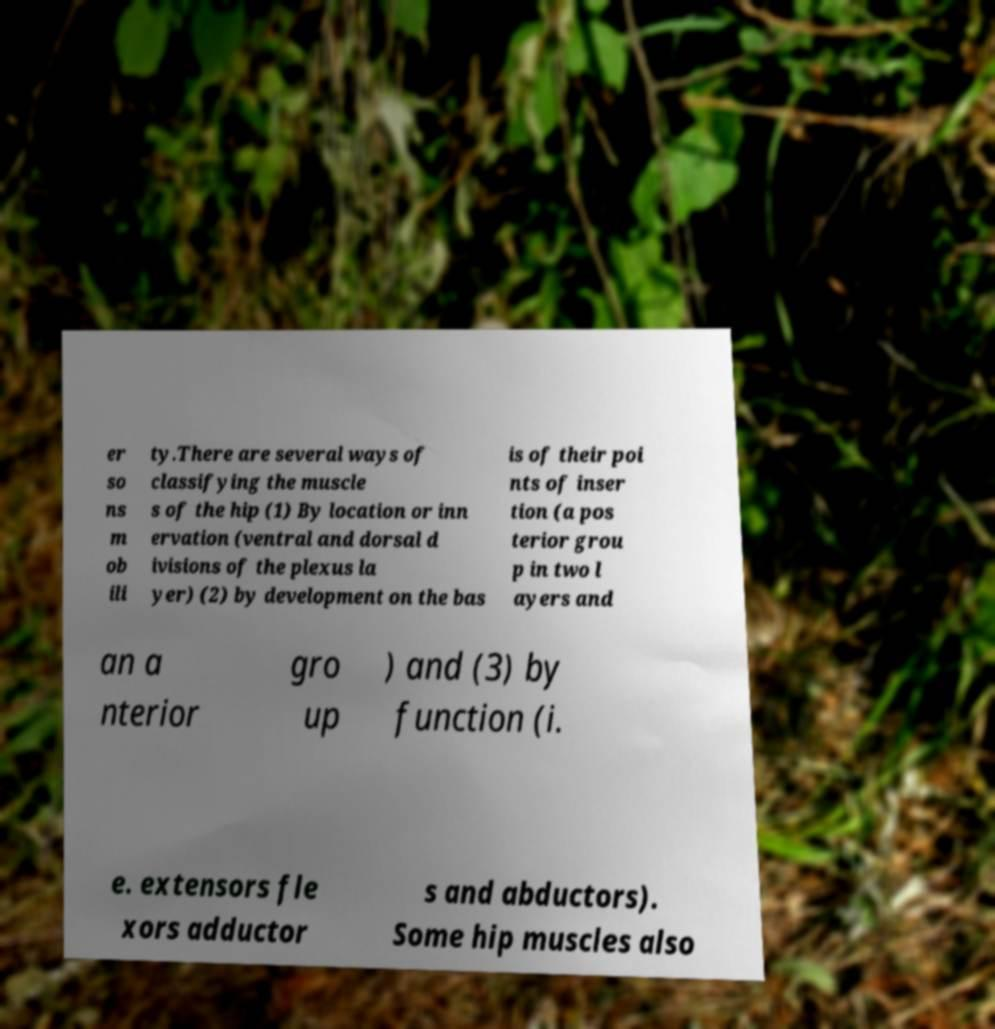I need the written content from this picture converted into text. Can you do that? er so ns m ob ili ty.There are several ways of classifying the muscle s of the hip (1) By location or inn ervation (ventral and dorsal d ivisions of the plexus la yer) (2) by development on the bas is of their poi nts of inser tion (a pos terior grou p in two l ayers and an a nterior gro up ) and (3) by function (i. e. extensors fle xors adductor s and abductors). Some hip muscles also 